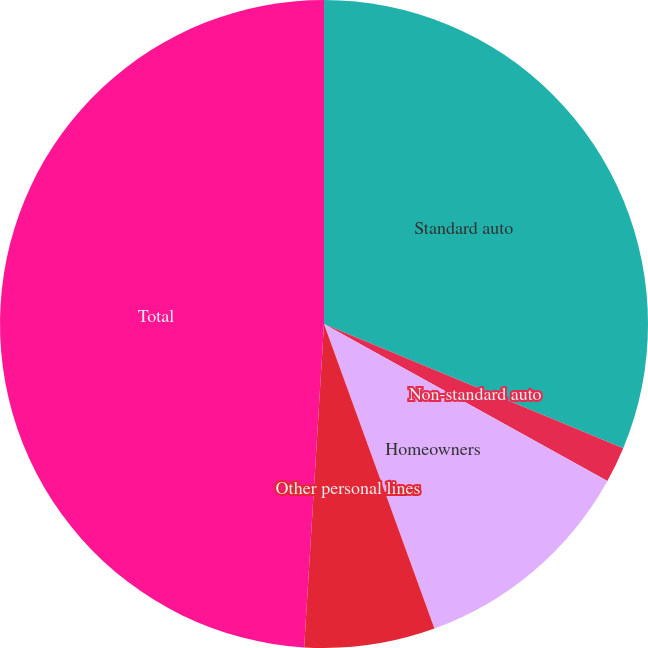<chart> <loc_0><loc_0><loc_500><loc_500><pie_chart><fcel>Standard auto<fcel>Non-standard auto<fcel>Homeowners<fcel>Other personal lines<fcel>Total<nl><fcel>31.26%<fcel>1.79%<fcel>11.41%<fcel>6.51%<fcel>49.02%<nl></chart> 